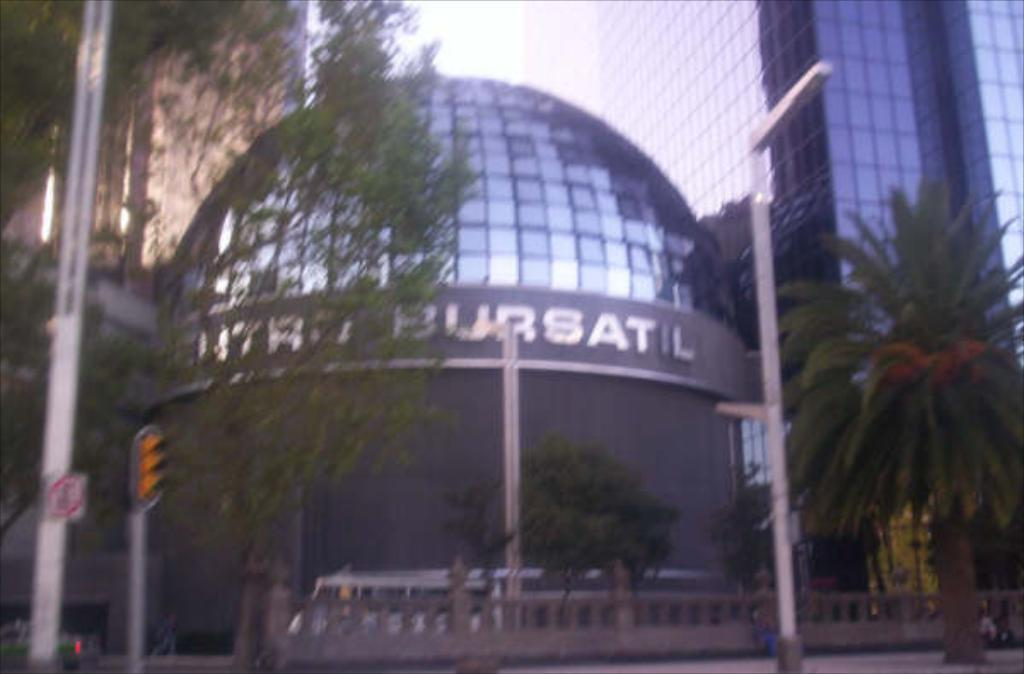What structures can be seen in the image? There are poles and many buildings in the image. What type of natural elements are present in the image? There are trees in the image. What can be seen in the background of the image? The sky is visible in the background of the image. How many cats are sleeping on the beds in the image? There are no cats or beds present in the image. 